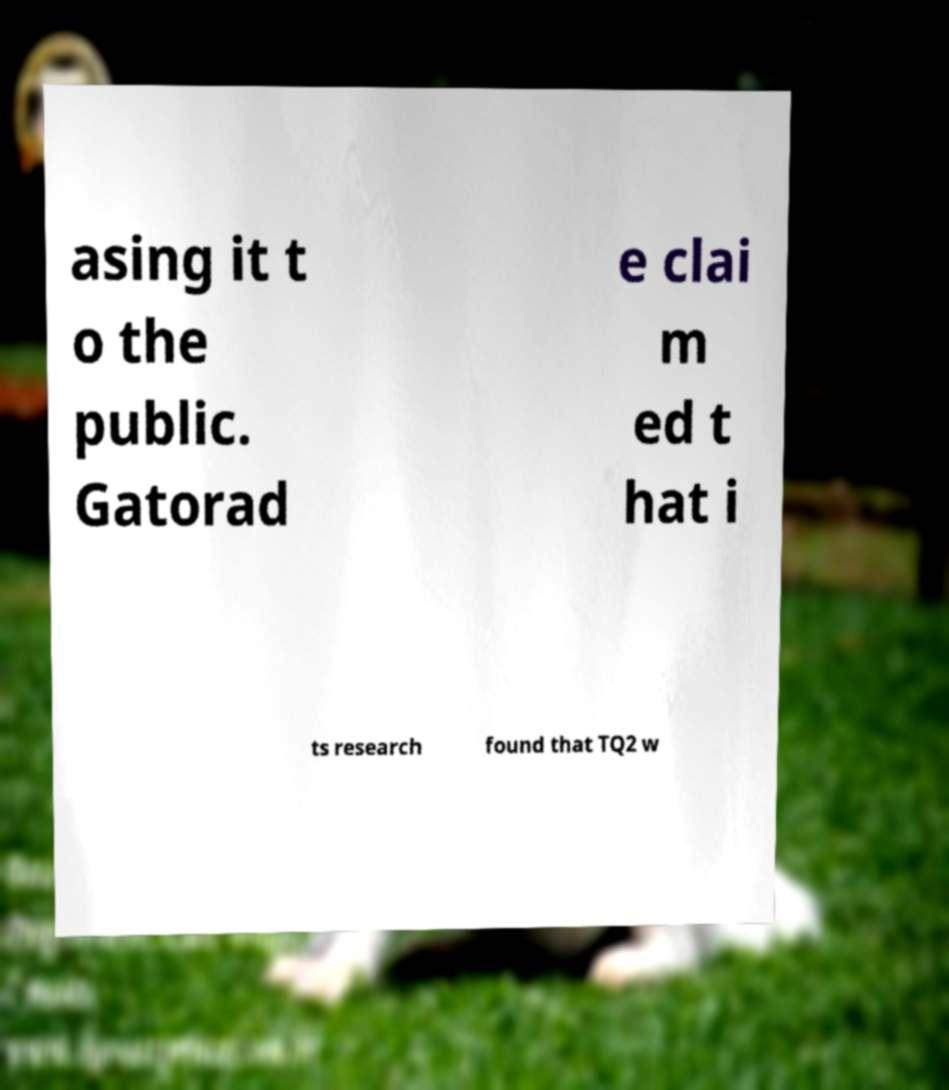Can you read and provide the text displayed in the image?This photo seems to have some interesting text. Can you extract and type it out for me? asing it t o the public. Gatorad e clai m ed t hat i ts research found that TQ2 w 